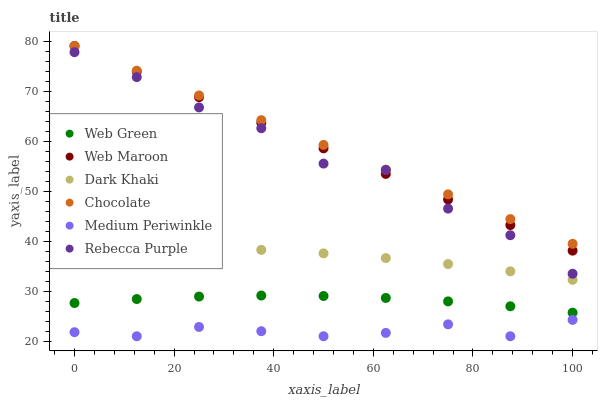Does Medium Periwinkle have the minimum area under the curve?
Answer yes or no. Yes. Does Chocolate have the maximum area under the curve?
Answer yes or no. Yes. Does Web Green have the minimum area under the curve?
Answer yes or no. No. Does Web Green have the maximum area under the curve?
Answer yes or no. No. Is Web Maroon the smoothest?
Answer yes or no. Yes. Is Rebecca Purple the roughest?
Answer yes or no. Yes. Is Medium Periwinkle the smoothest?
Answer yes or no. No. Is Medium Periwinkle the roughest?
Answer yes or no. No. Does Medium Periwinkle have the lowest value?
Answer yes or no. Yes. Does Web Green have the lowest value?
Answer yes or no. No. Does Chocolate have the highest value?
Answer yes or no. Yes. Does Web Green have the highest value?
Answer yes or no. No. Is Medium Periwinkle less than Chocolate?
Answer yes or no. Yes. Is Web Green greater than Medium Periwinkle?
Answer yes or no. Yes. Does Chocolate intersect Web Maroon?
Answer yes or no. Yes. Is Chocolate less than Web Maroon?
Answer yes or no. No. Is Chocolate greater than Web Maroon?
Answer yes or no. No. Does Medium Periwinkle intersect Chocolate?
Answer yes or no. No. 